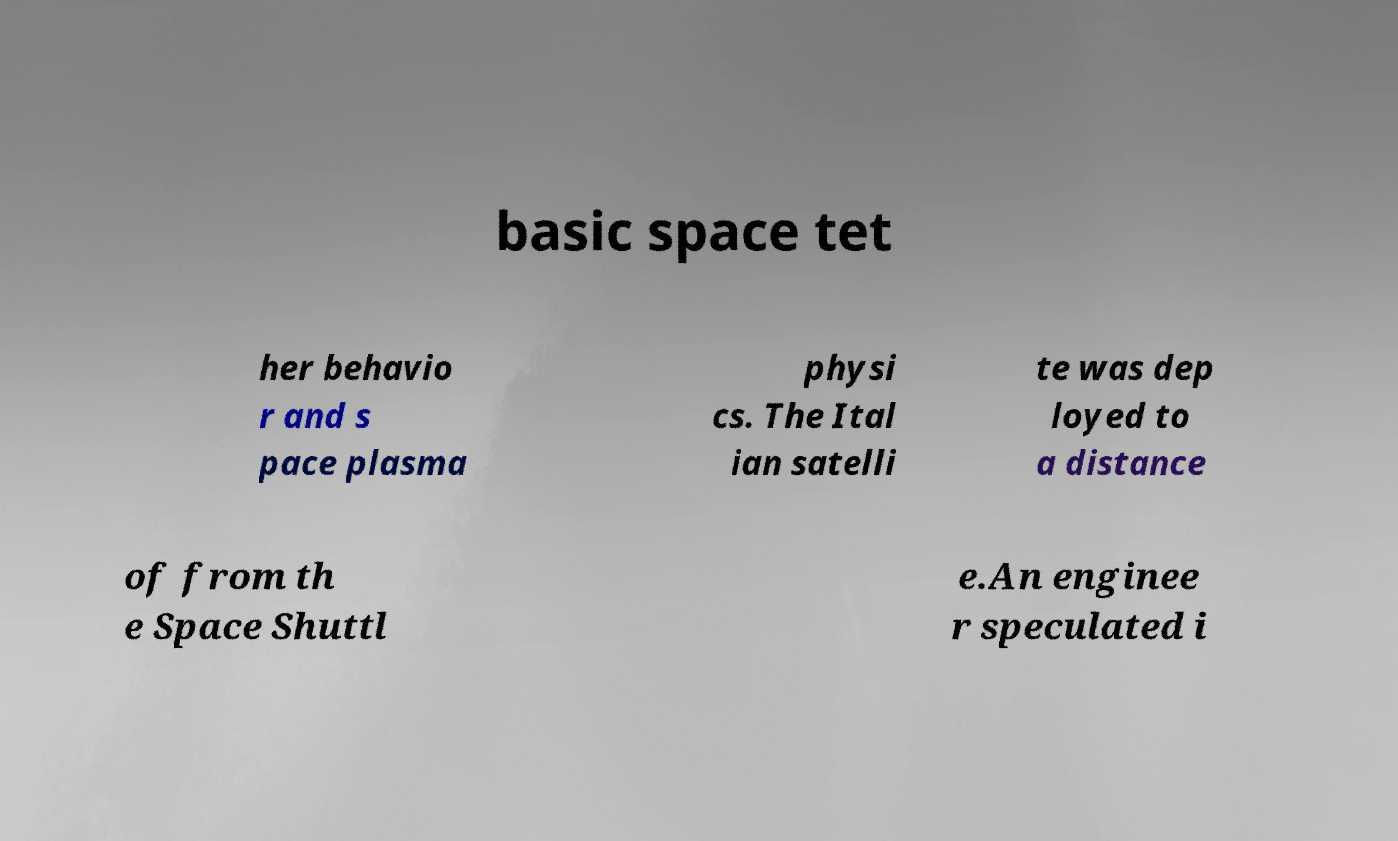For documentation purposes, I need the text within this image transcribed. Could you provide that? basic space tet her behavio r and s pace plasma physi cs. The Ital ian satelli te was dep loyed to a distance of from th e Space Shuttl e.An enginee r speculated i 